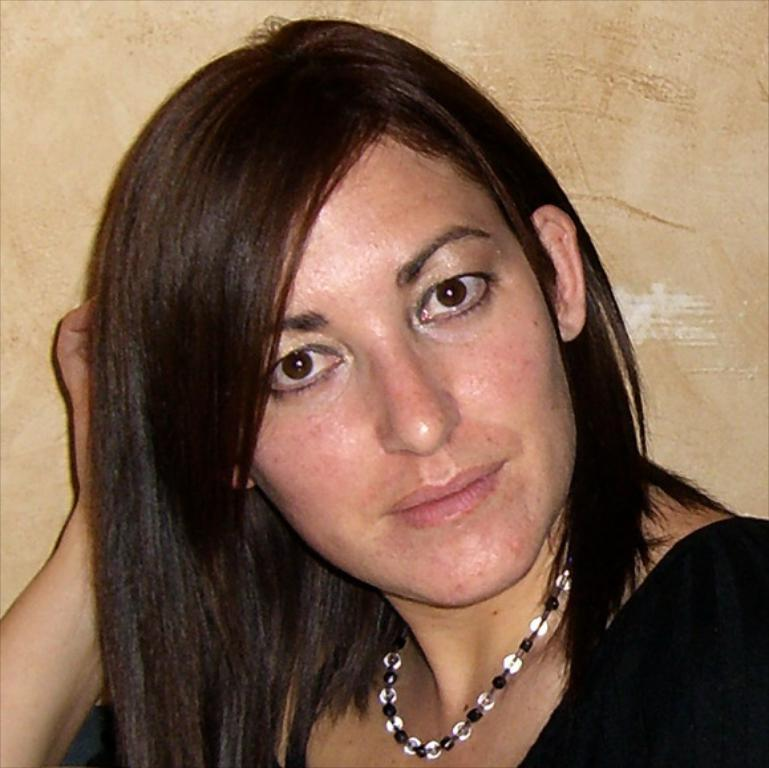Who is in the image? There is a woman in the image. What is the woman wearing around her neck? The woman is wearing a pearl necklace. What color is the dress the woman is wearing? The woman is wearing a black dress. What level of difficulty is the woman playing on her musical instrument in the image? There is no musical instrument present in the image, so it is not possible to determine the level of difficulty the woman might be playing at. 